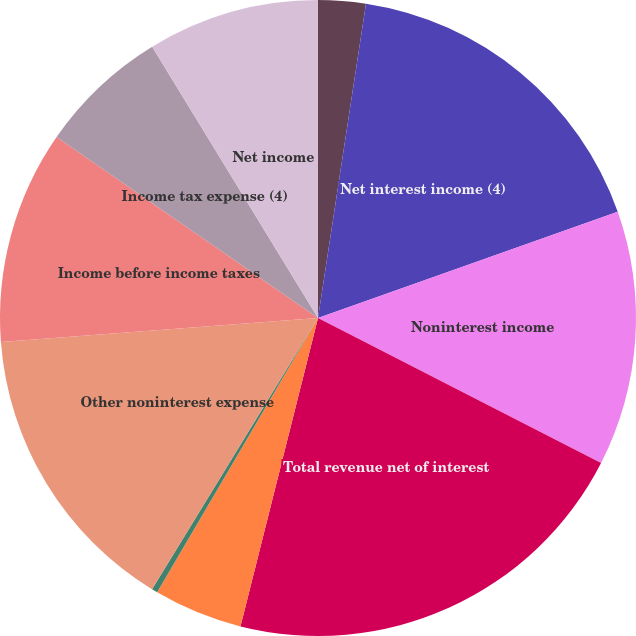Convert chart. <chart><loc_0><loc_0><loc_500><loc_500><pie_chart><fcel>(Dollars in millions)<fcel>Net interest income (4)<fcel>Noninterest income<fcel>Total revenue net of interest<fcel>Provision for credit losses<fcel>Amortization of intangibles<fcel>Other noninterest expense<fcel>Income before income taxes<fcel>Income tax expense (4)<fcel>Net income<nl><fcel>2.41%<fcel>17.17%<fcel>12.95%<fcel>21.39%<fcel>4.52%<fcel>0.3%<fcel>15.06%<fcel>10.84%<fcel>6.63%<fcel>8.73%<nl></chart> 